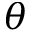<formula> <loc_0><loc_0><loc_500><loc_500>\theta</formula> 